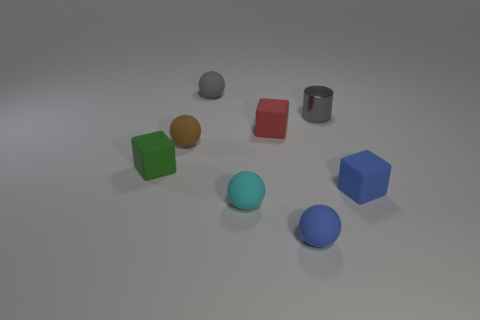There is a blue rubber object that is in front of the blue thing to the right of the small matte sphere that is to the right of the red block; how big is it?
Give a very brief answer. Small. Are there any other things that are the same size as the cyan object?
Your answer should be very brief. Yes. What number of small rubber things are right of the red thing?
Ensure brevity in your answer.  2. Are there the same number of small gray spheres that are in front of the small green rubber object and big red rubber things?
Ensure brevity in your answer.  Yes. How many things are tiny brown metal cylinders or tiny cubes?
Provide a succinct answer. 3. Are there any other things that are the same shape as the cyan rubber object?
Your response must be concise. Yes. There is a matte thing that is to the left of the sphere on the left side of the small gray rubber sphere; what shape is it?
Offer a very short reply. Cube. There is a tiny brown thing that is made of the same material as the small red thing; what shape is it?
Give a very brief answer. Sphere. There is a cyan ball that is to the left of the small blue matte thing that is in front of the tiny blue rubber cube; how big is it?
Keep it short and to the point. Small. There is a small red object; what shape is it?
Provide a short and direct response. Cube. 